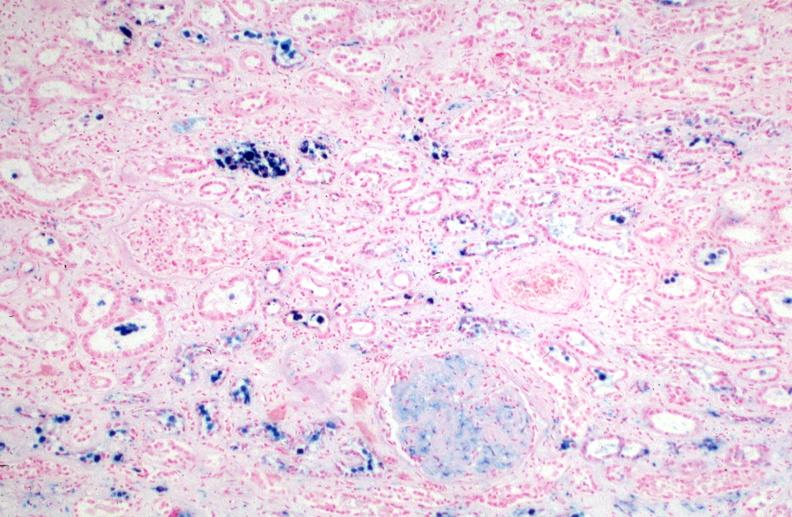what is hemosiderosis caused?
Answer the question using a single word or phrase. By numerous blood transfusions.prusian blue 